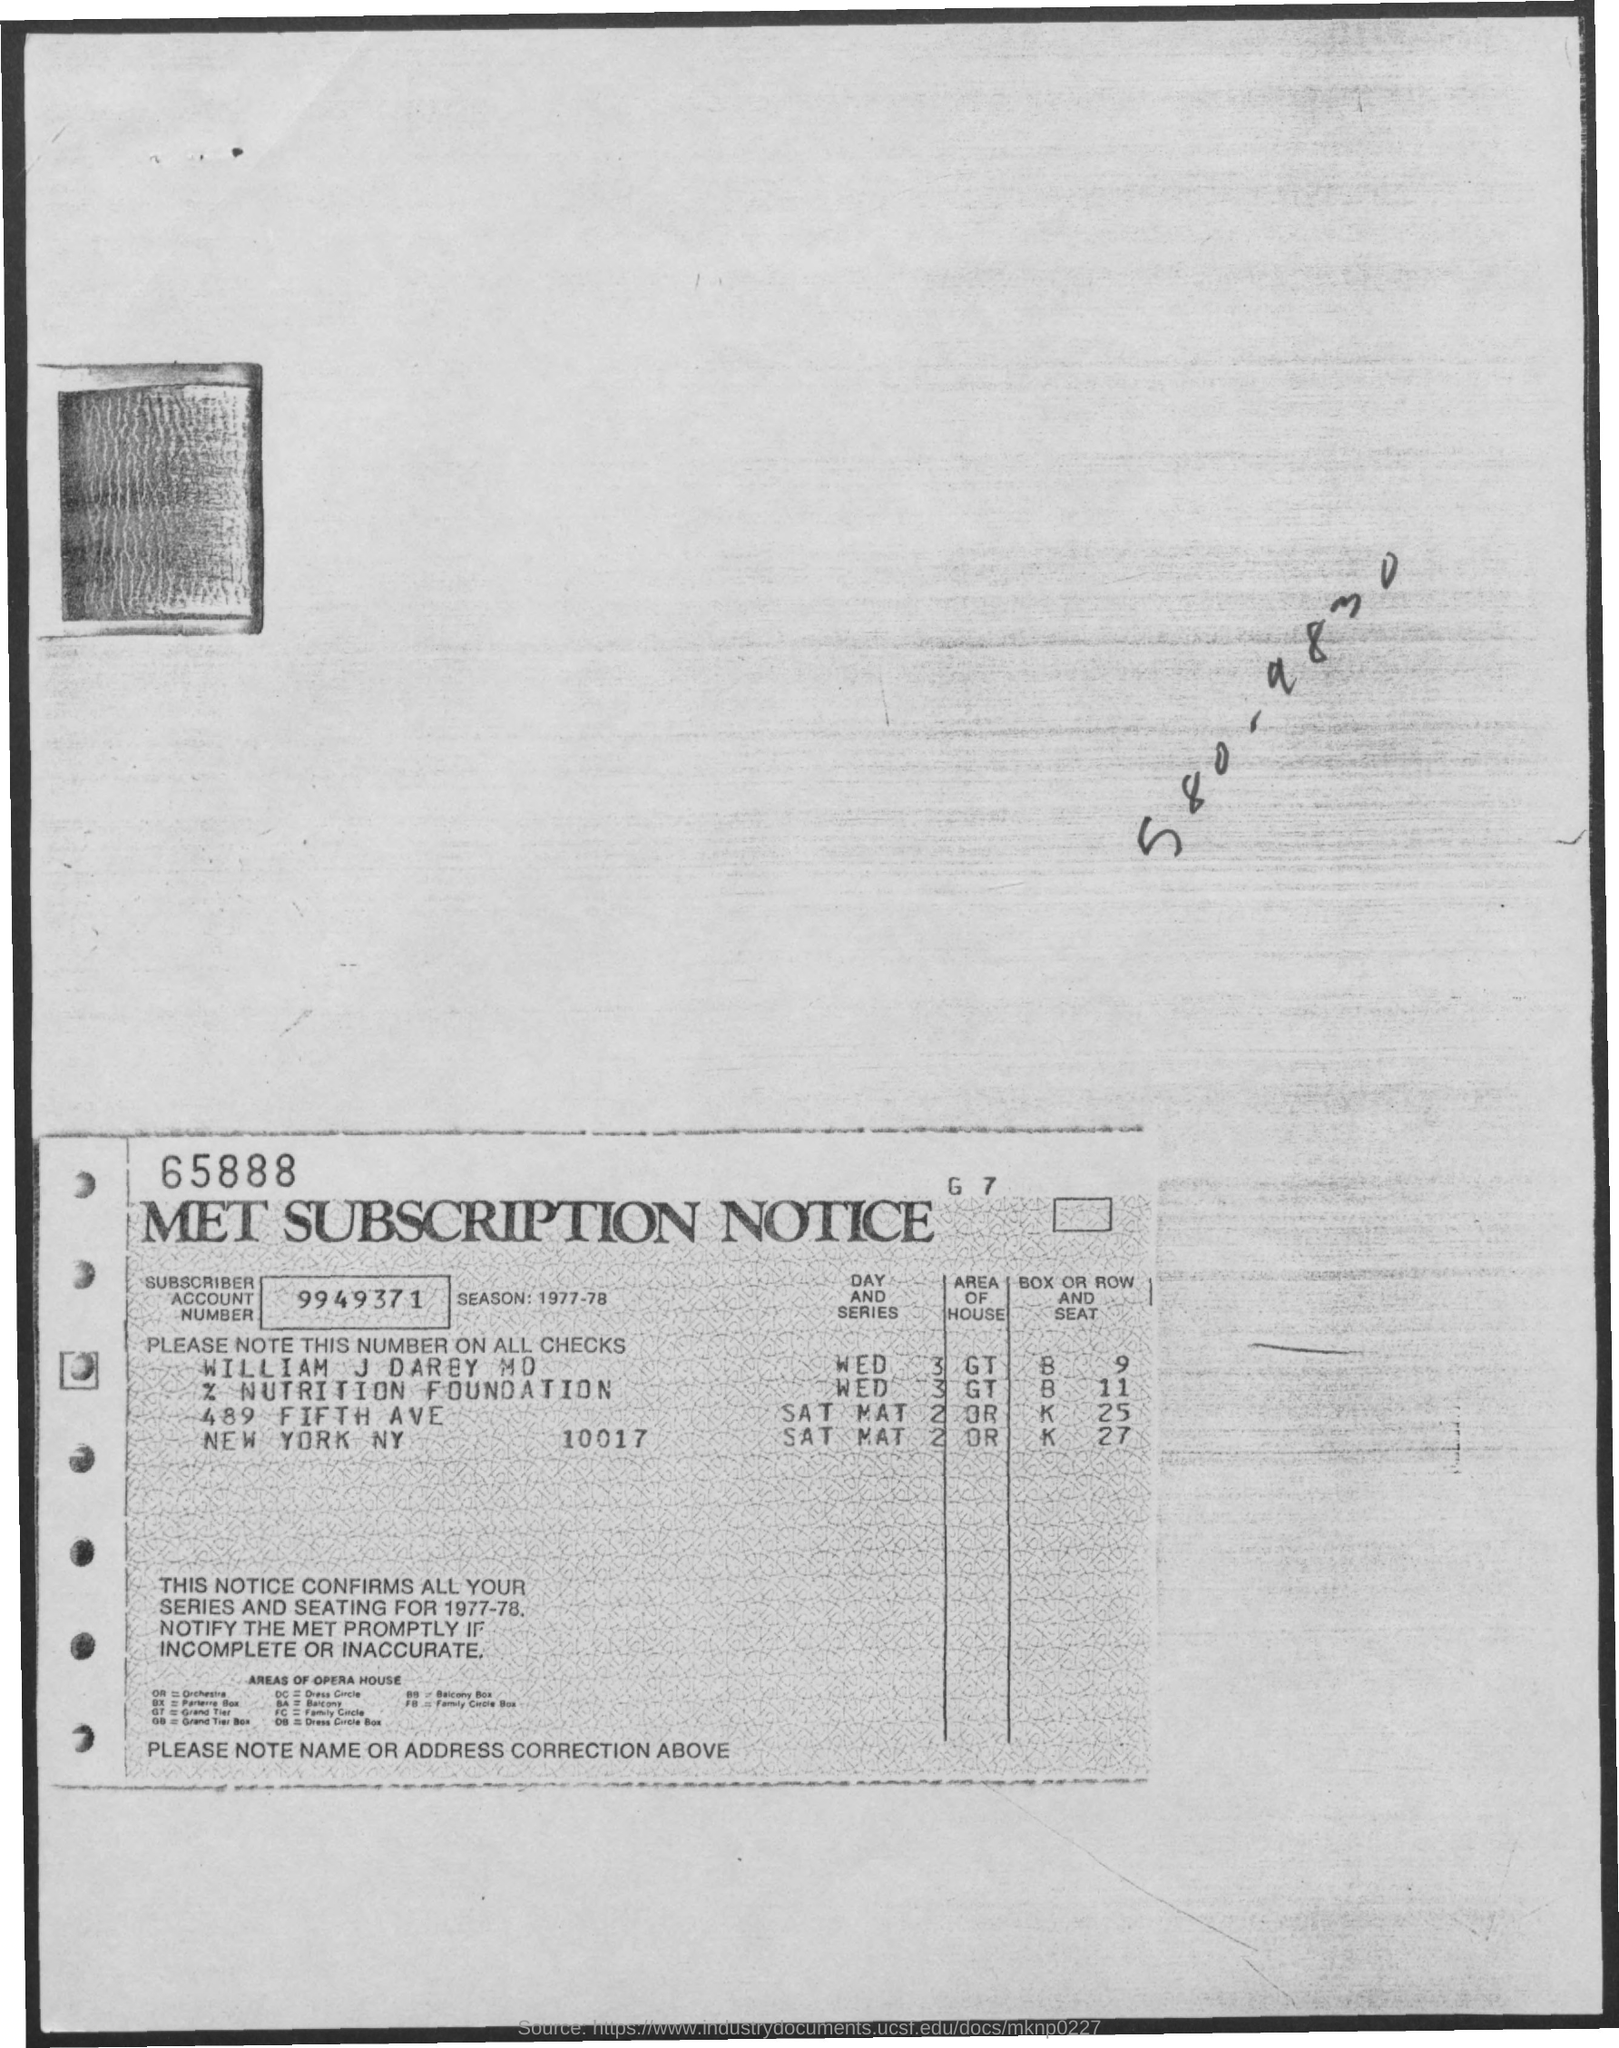What is the Account Number?
Ensure brevity in your answer.  9949371. 